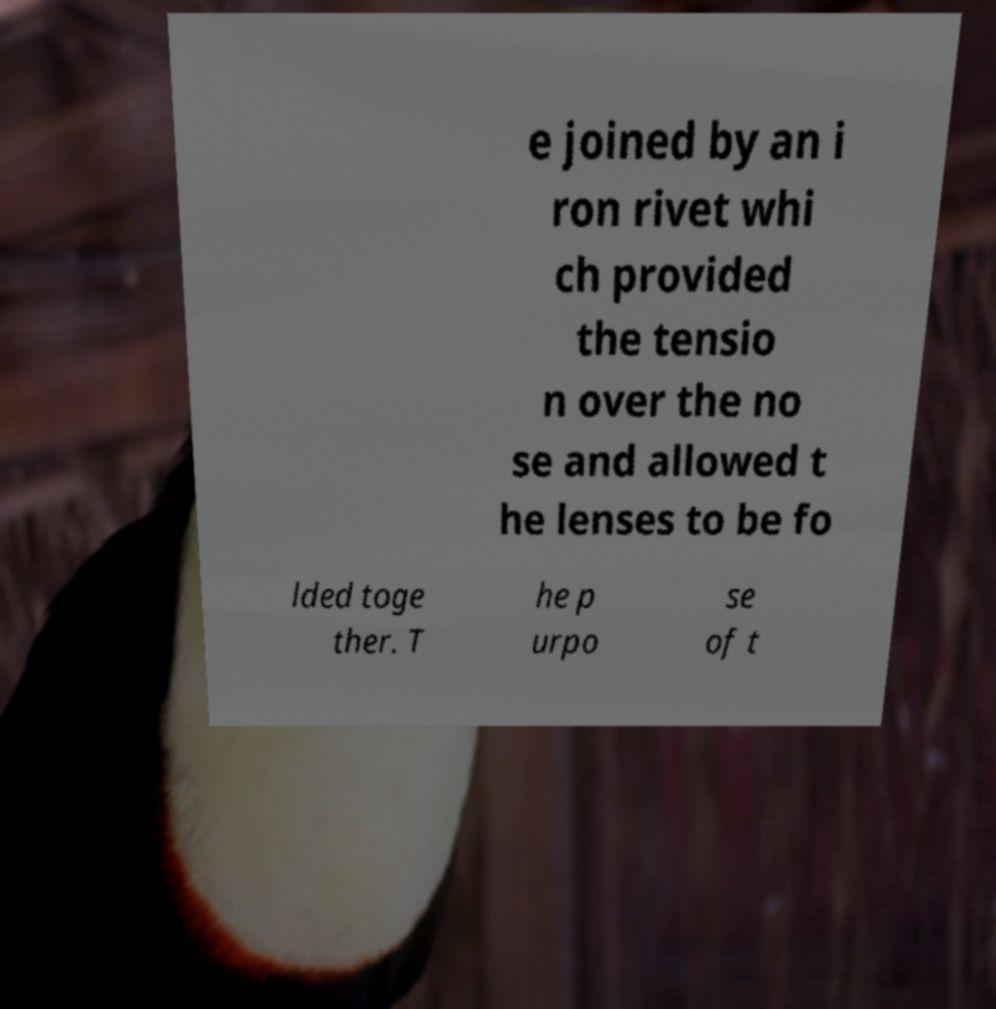Please identify and transcribe the text found in this image. e joined by an i ron rivet whi ch provided the tensio n over the no se and allowed t he lenses to be fo lded toge ther. T he p urpo se of t 